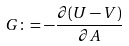<formula> <loc_0><loc_0><loc_500><loc_500>G \colon = - \frac { \partial ( U - V ) } { \partial A }</formula> 